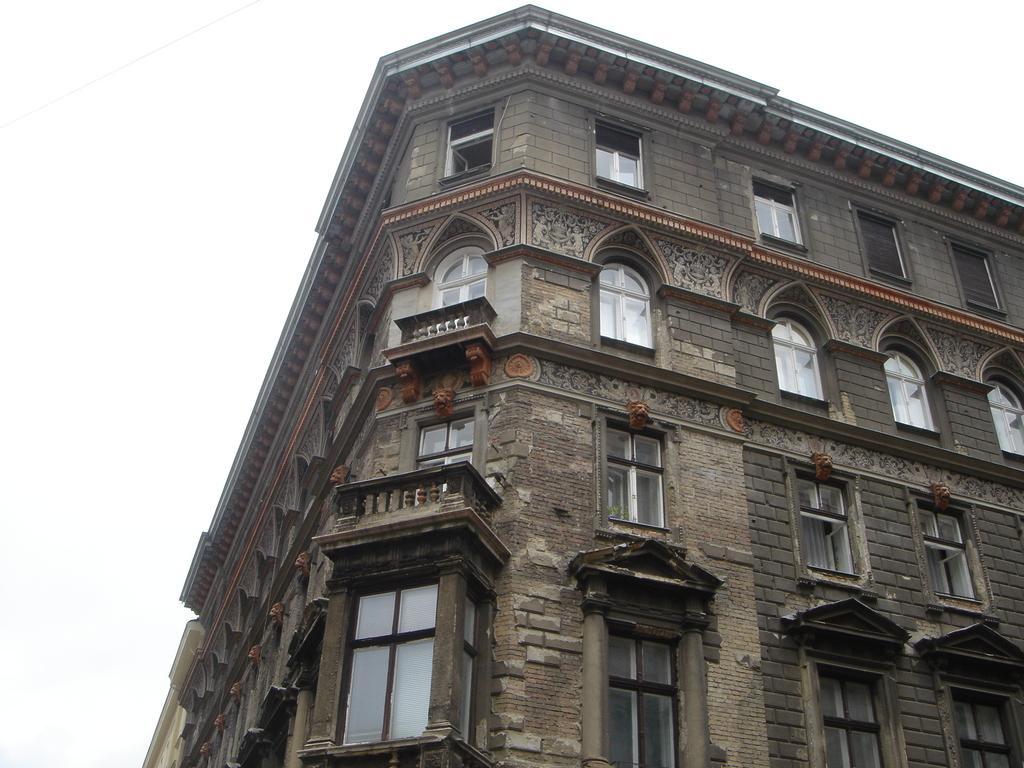Please provide a concise description of this image. In this image there is a building and in front there are windows, balconies. 